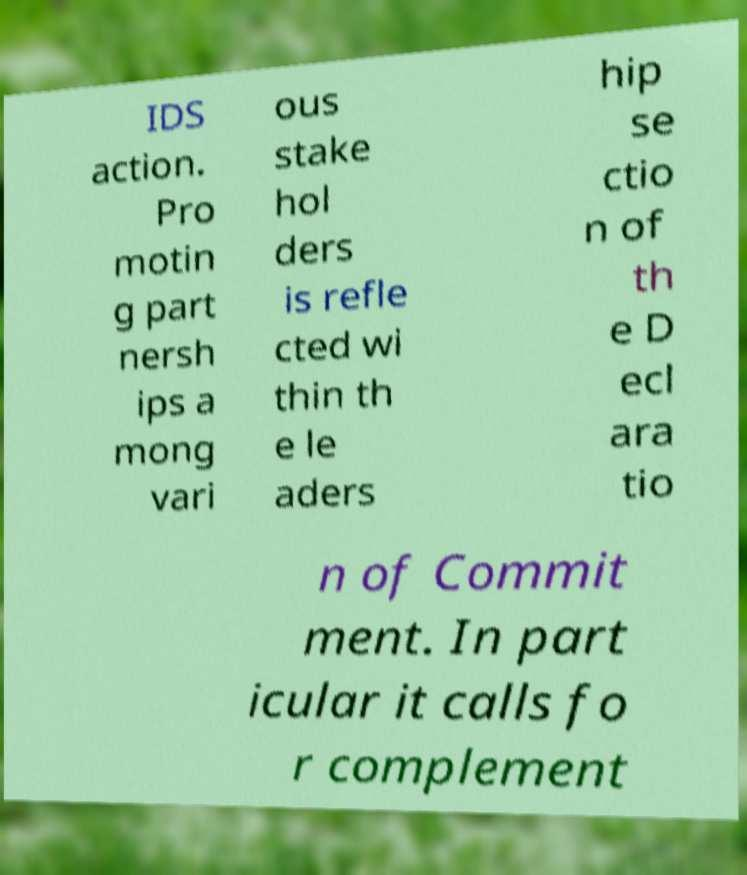There's text embedded in this image that I need extracted. Can you transcribe it verbatim? IDS action. Pro motin g part nersh ips a mong vari ous stake hol ders is refle cted wi thin th e le aders hip se ctio n of th e D ecl ara tio n of Commit ment. In part icular it calls fo r complement 